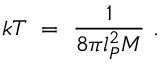<formula> <loc_0><loc_0><loc_500><loc_500>k T \ = \ \frac { 1 } { 8 \pi l _ { P } ^ { 2 } M } \ .</formula> 